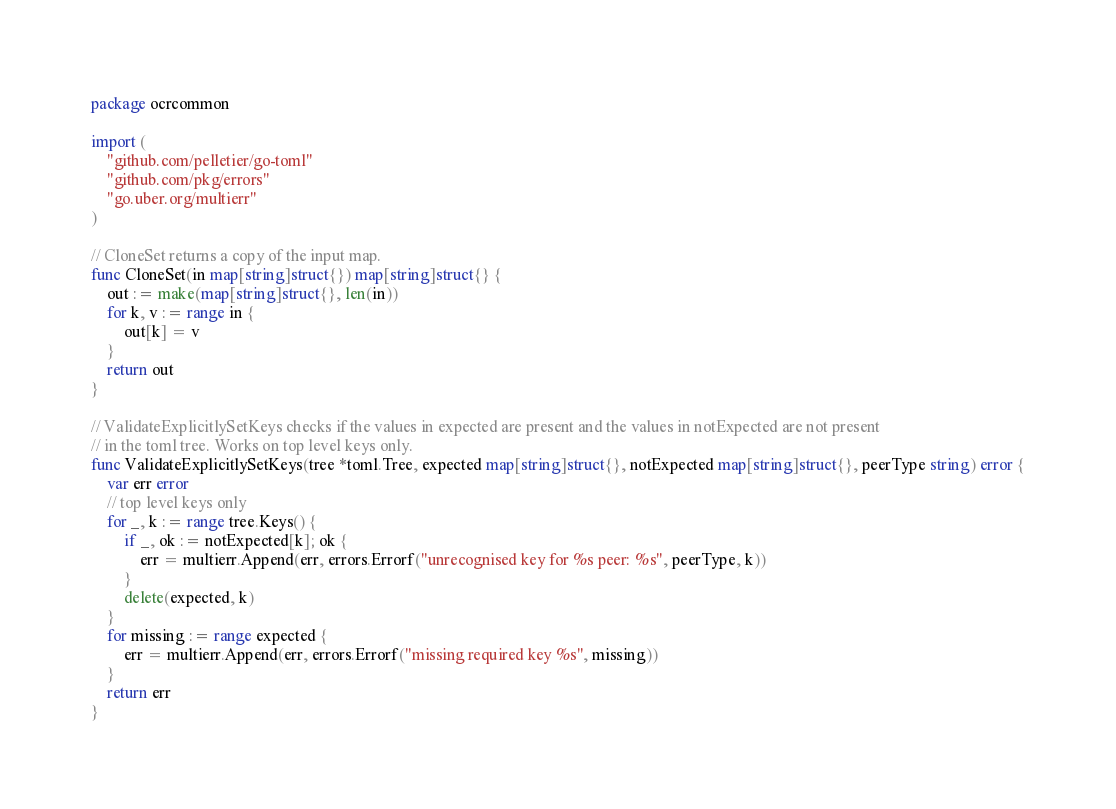Convert code to text. <code><loc_0><loc_0><loc_500><loc_500><_Go_>package ocrcommon

import (
	"github.com/pelletier/go-toml"
	"github.com/pkg/errors"
	"go.uber.org/multierr"
)

// CloneSet returns a copy of the input map.
func CloneSet(in map[string]struct{}) map[string]struct{} {
	out := make(map[string]struct{}, len(in))
	for k, v := range in {
		out[k] = v
	}
	return out
}

// ValidateExplicitlySetKeys checks if the values in expected are present and the values in notExpected are not present
// in the toml tree. Works on top level keys only.
func ValidateExplicitlySetKeys(tree *toml.Tree, expected map[string]struct{}, notExpected map[string]struct{}, peerType string) error {
	var err error
	// top level keys only
	for _, k := range tree.Keys() {
		if _, ok := notExpected[k]; ok {
			err = multierr.Append(err, errors.Errorf("unrecognised key for %s peer: %s", peerType, k))
		}
		delete(expected, k)
	}
	for missing := range expected {
		err = multierr.Append(err, errors.Errorf("missing required key %s", missing))
	}
	return err
}
</code> 